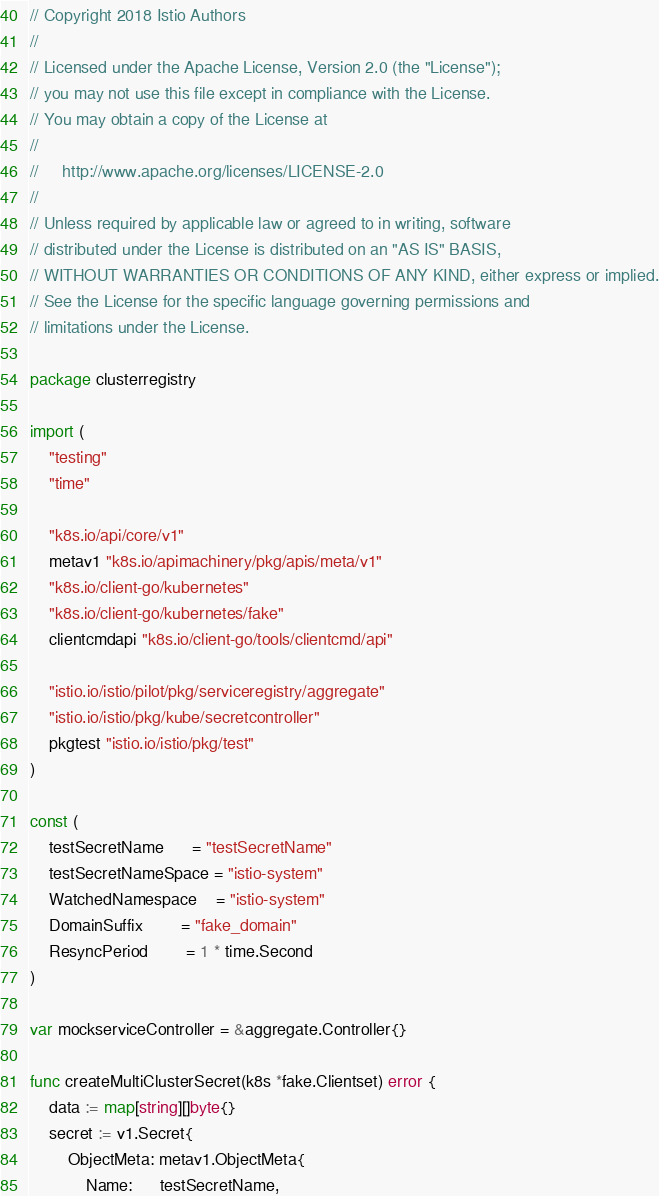<code> <loc_0><loc_0><loc_500><loc_500><_Go_>// Copyright 2018 Istio Authors
//
// Licensed under the Apache License, Version 2.0 (the "License");
// you may not use this file except in compliance with the License.
// You may obtain a copy of the License at
//
//     http://www.apache.org/licenses/LICENSE-2.0
//
// Unless required by applicable law or agreed to in writing, software
// distributed under the License is distributed on an "AS IS" BASIS,
// WITHOUT WARRANTIES OR CONDITIONS OF ANY KIND, either express or implied.
// See the License for the specific language governing permissions and
// limitations under the License.

package clusterregistry

import (
	"testing"
	"time"

	"k8s.io/api/core/v1"
	metav1 "k8s.io/apimachinery/pkg/apis/meta/v1"
	"k8s.io/client-go/kubernetes"
	"k8s.io/client-go/kubernetes/fake"
	clientcmdapi "k8s.io/client-go/tools/clientcmd/api"

	"istio.io/istio/pilot/pkg/serviceregistry/aggregate"
	"istio.io/istio/pkg/kube/secretcontroller"
	pkgtest "istio.io/istio/pkg/test"
)

const (
	testSecretName      = "testSecretName"
	testSecretNameSpace = "istio-system"
	WatchedNamespace    = "istio-system"
	DomainSuffix        = "fake_domain"
	ResyncPeriod        = 1 * time.Second
)

var mockserviceController = &aggregate.Controller{}

func createMultiClusterSecret(k8s *fake.Clientset) error {
	data := map[string][]byte{}
	secret := v1.Secret{
		ObjectMeta: metav1.ObjectMeta{
			Name:      testSecretName,</code> 